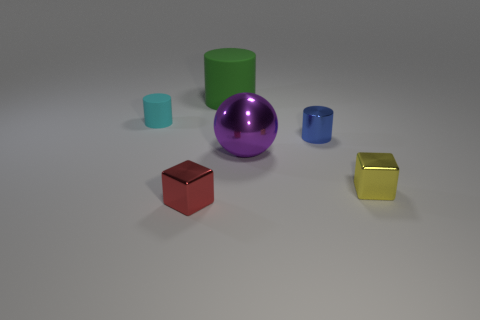Add 2 small gray metal cubes. How many objects exist? 8 Subtract all balls. How many objects are left? 5 Subtract 0 green spheres. How many objects are left? 6 Subtract all tiny yellow shiny cubes. Subtract all purple spheres. How many objects are left? 4 Add 6 green matte cylinders. How many green matte cylinders are left? 7 Add 1 large gray rubber objects. How many large gray rubber objects exist? 1 